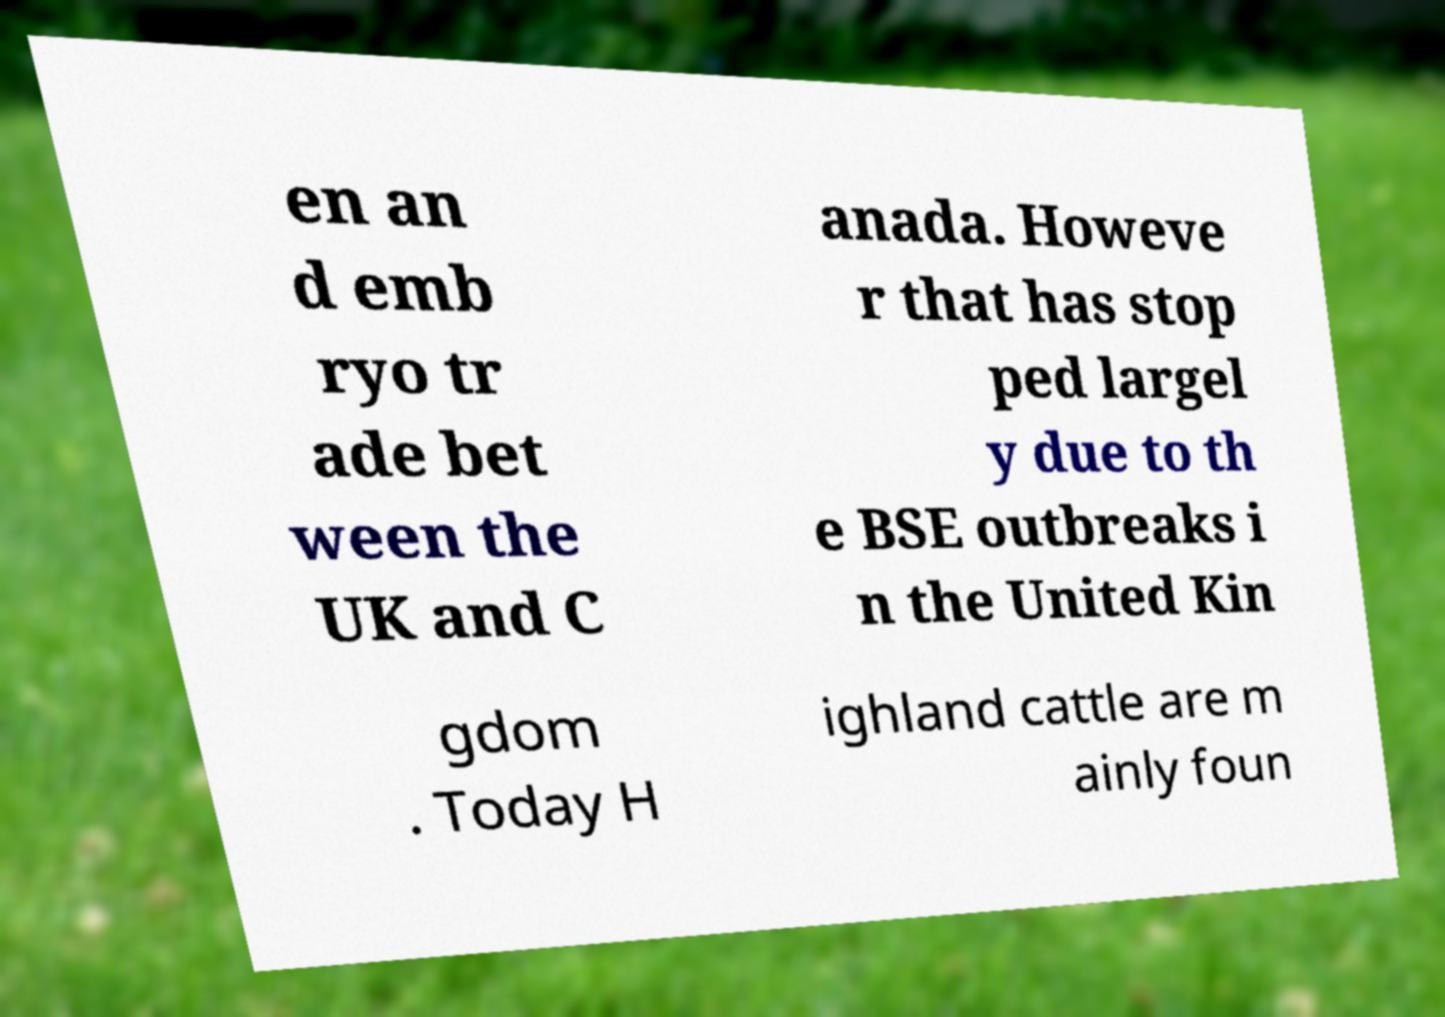Could you extract and type out the text from this image? en an d emb ryo tr ade bet ween the UK and C anada. Howeve r that has stop ped largel y due to th e BSE outbreaks i n the United Kin gdom . Today H ighland cattle are m ainly foun 